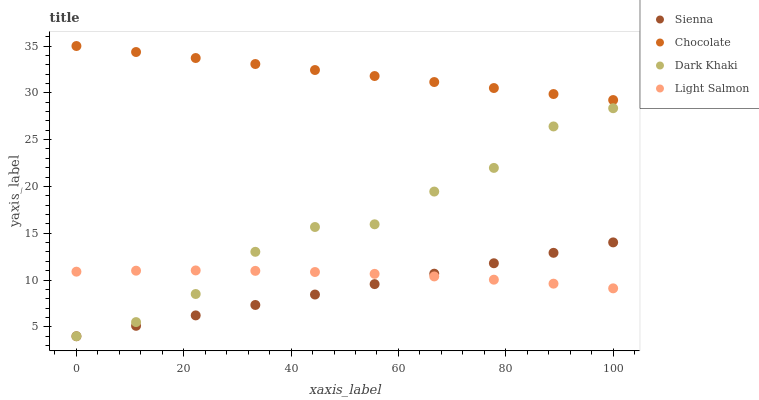Does Sienna have the minimum area under the curve?
Answer yes or no. Yes. Does Chocolate have the maximum area under the curve?
Answer yes or no. Yes. Does Dark Khaki have the minimum area under the curve?
Answer yes or no. No. Does Dark Khaki have the maximum area under the curve?
Answer yes or no. No. Is Sienna the smoothest?
Answer yes or no. Yes. Is Dark Khaki the roughest?
Answer yes or no. Yes. Is Light Salmon the smoothest?
Answer yes or no. No. Is Light Salmon the roughest?
Answer yes or no. No. Does Sienna have the lowest value?
Answer yes or no. Yes. Does Light Salmon have the lowest value?
Answer yes or no. No. Does Chocolate have the highest value?
Answer yes or no. Yes. Does Dark Khaki have the highest value?
Answer yes or no. No. Is Dark Khaki less than Chocolate?
Answer yes or no. Yes. Is Chocolate greater than Dark Khaki?
Answer yes or no. Yes. Does Light Salmon intersect Dark Khaki?
Answer yes or no. Yes. Is Light Salmon less than Dark Khaki?
Answer yes or no. No. Is Light Salmon greater than Dark Khaki?
Answer yes or no. No. Does Dark Khaki intersect Chocolate?
Answer yes or no. No. 